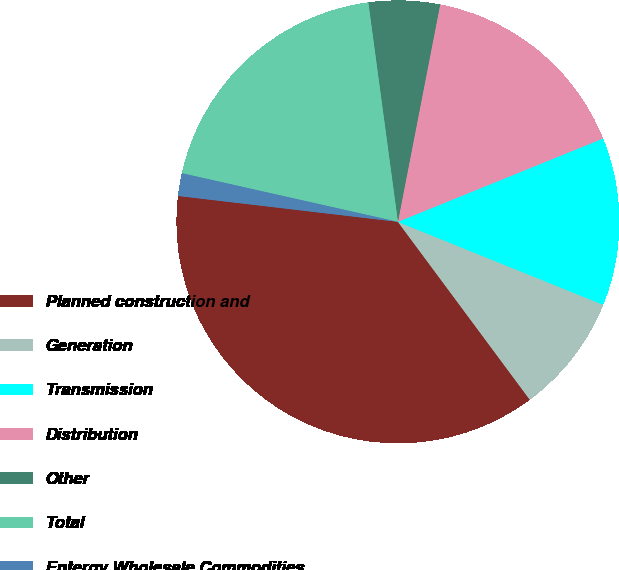<chart> <loc_0><loc_0><loc_500><loc_500><pie_chart><fcel>Planned construction and<fcel>Generation<fcel>Transmission<fcel>Distribution<fcel>Other<fcel>Total<fcel>Entergy Wholesale Commodities<nl><fcel>37.02%<fcel>8.73%<fcel>12.26%<fcel>15.8%<fcel>5.19%<fcel>19.34%<fcel>1.66%<nl></chart> 